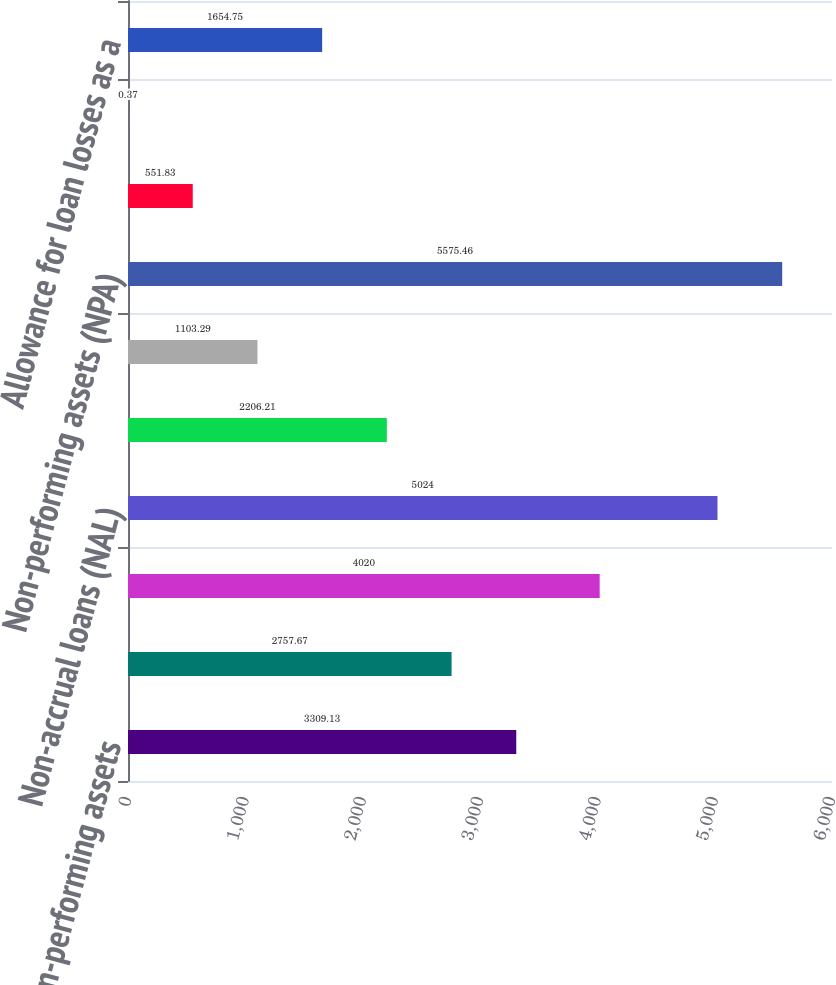Convert chart. <chart><loc_0><loc_0><loc_500><loc_500><bar_chart><fcel>Non-performing assets<fcel>Corporate non-accrual loans<fcel>Consumer non-accrual loans<fcel>Non-accrual loans (NAL)<fcel>OREO<fcel>Other repossessed assets<fcel>Non-performing assets (NPA)<fcel>NAL as a of total loans<fcel>NPA as a of total assets<fcel>Allowance for loan losses as a<nl><fcel>3309.13<fcel>2757.67<fcel>4020<fcel>5024<fcel>2206.21<fcel>1103.29<fcel>5575.46<fcel>551.83<fcel>0.37<fcel>1654.75<nl></chart> 